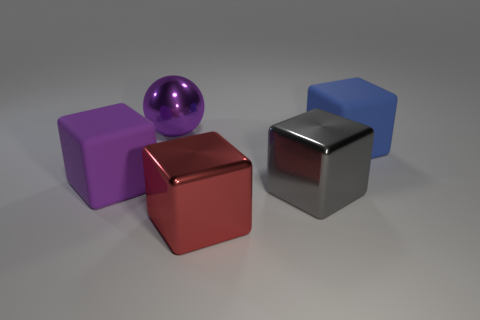Subtract all red shiny blocks. How many blocks are left? 3 Add 2 small blue shiny balls. How many objects exist? 7 Subtract all gray cubes. How many cubes are left? 3 Subtract all cubes. How many objects are left? 1 Subtract 1 spheres. How many spheres are left? 0 Subtract all green spheres. Subtract all red cylinders. How many spheres are left? 1 Subtract all gray matte blocks. Subtract all blocks. How many objects are left? 1 Add 2 large purple cubes. How many large purple cubes are left? 3 Add 5 red shiny blocks. How many red shiny blocks exist? 6 Subtract 0 yellow blocks. How many objects are left? 5 